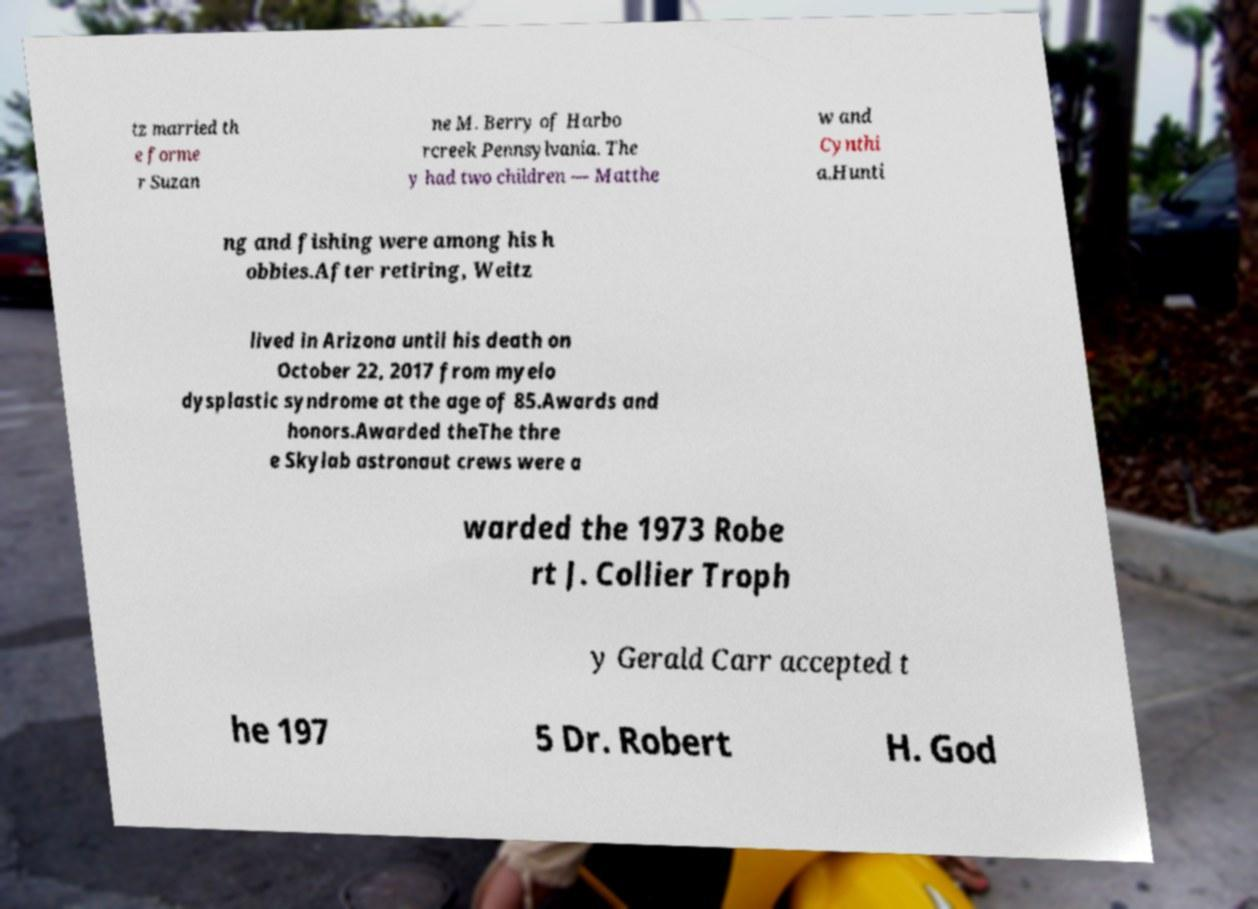I need the written content from this picture converted into text. Can you do that? tz married th e forme r Suzan ne M. Berry of Harbo rcreek Pennsylvania. The y had two children — Matthe w and Cynthi a.Hunti ng and fishing were among his h obbies.After retiring, Weitz lived in Arizona until his death on October 22, 2017 from myelo dysplastic syndrome at the age of 85.Awards and honors.Awarded theThe thre e Skylab astronaut crews were a warded the 1973 Robe rt J. Collier Troph y Gerald Carr accepted t he 197 5 Dr. Robert H. God 